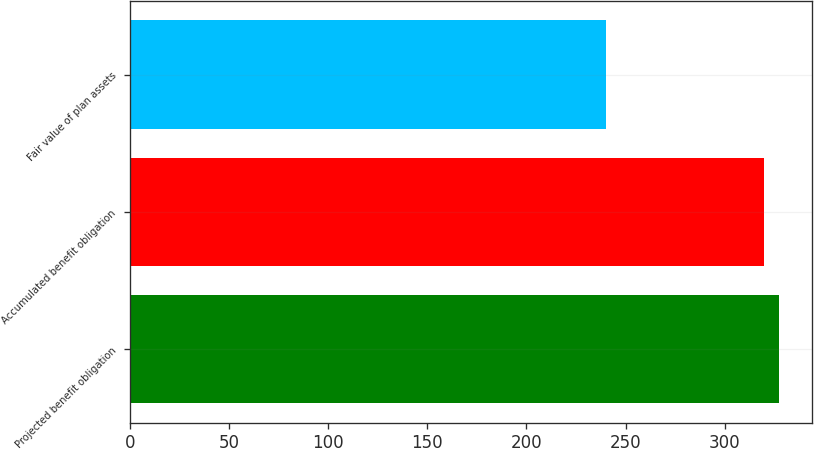Convert chart to OTSL. <chart><loc_0><loc_0><loc_500><loc_500><bar_chart><fcel>Projected benefit obligation<fcel>Accumulated benefit obligation<fcel>Fair value of plan assets<nl><fcel>327.54<fcel>319.92<fcel>240.3<nl></chart> 